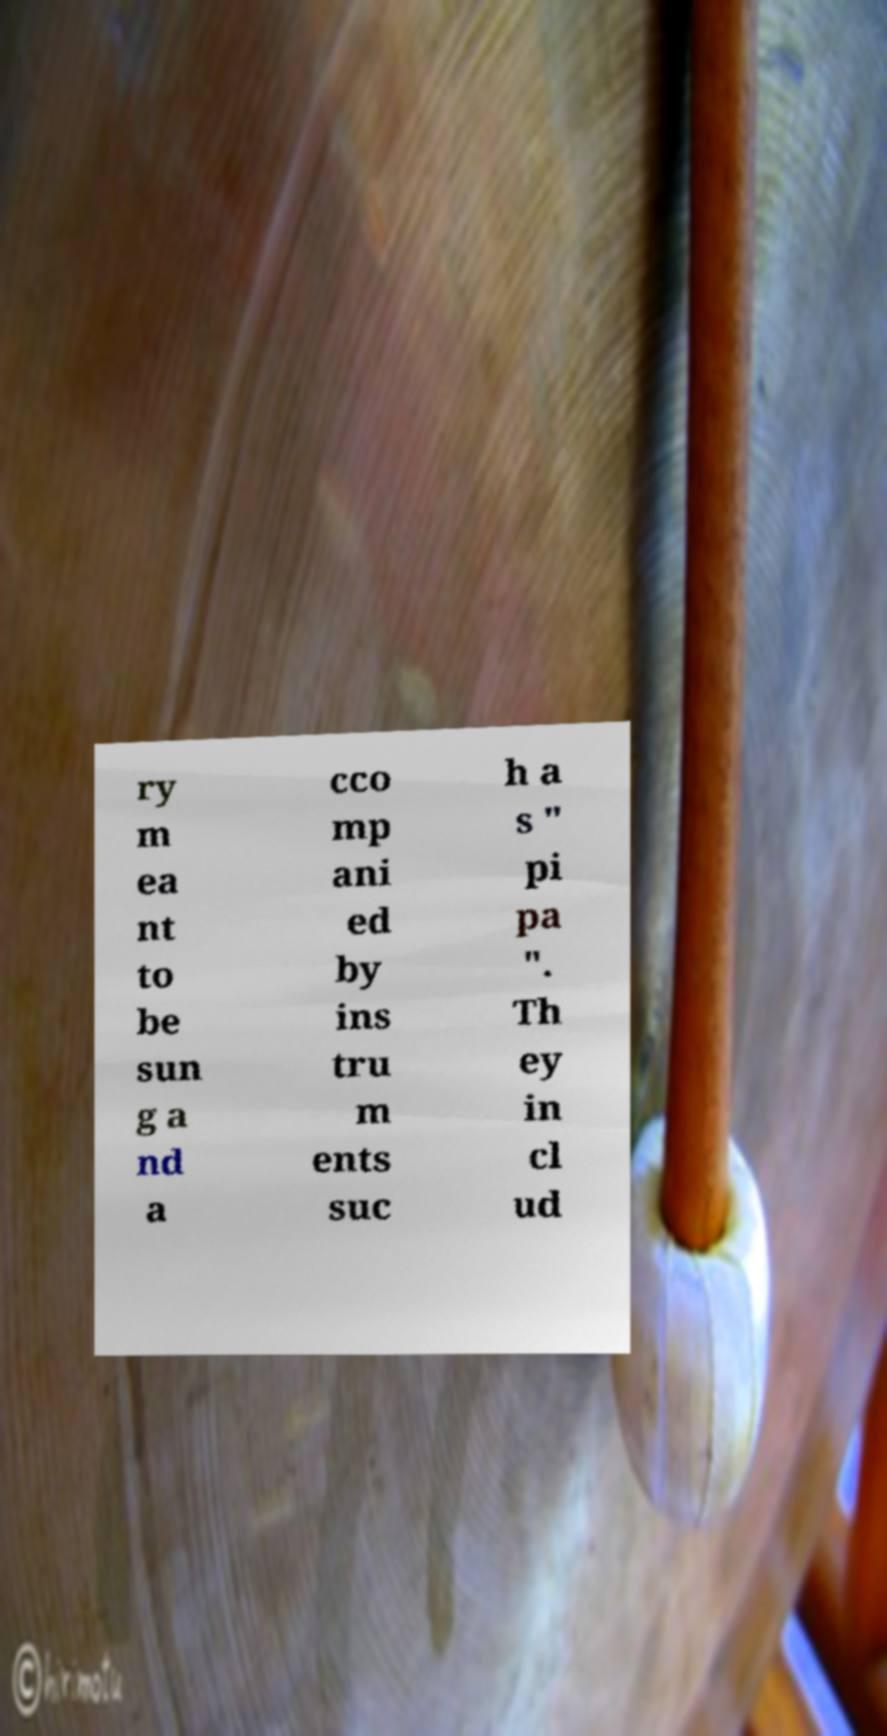Could you assist in decoding the text presented in this image and type it out clearly? ry m ea nt to be sun g a nd a cco mp ani ed by ins tru m ents suc h a s " pi pa ". Th ey in cl ud 